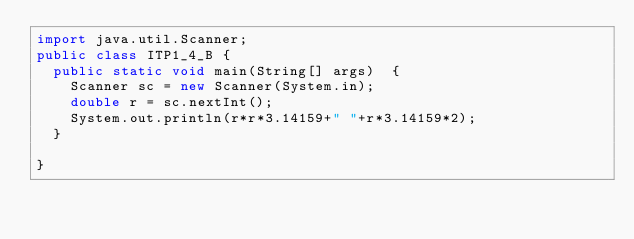<code> <loc_0><loc_0><loc_500><loc_500><_Java_>import java.util.Scanner;
public class ITP1_4_B {
	public static void main(String[] args)  {
		Scanner sc = new Scanner(System.in);
		double r = sc.nextInt();
		System.out.println(r*r*3.14159+" "+r*3.14159*2);
	}

}</code> 